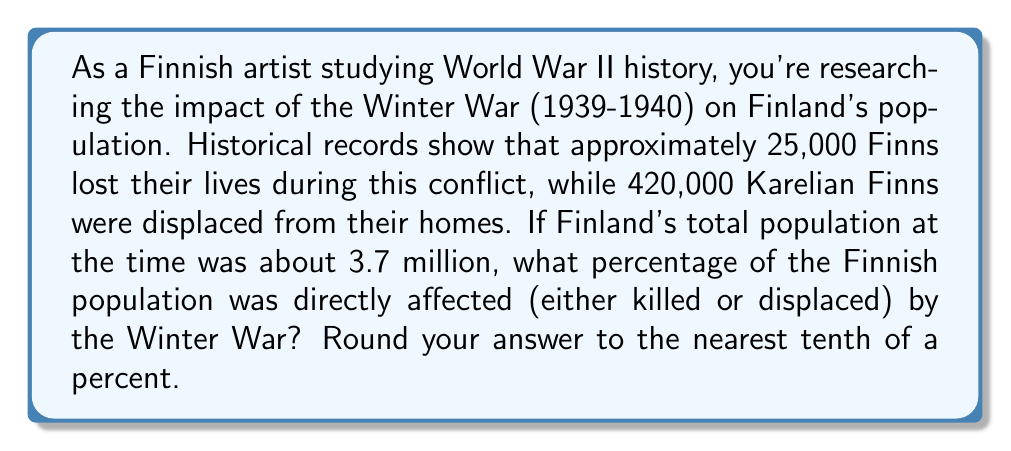What is the answer to this math problem? To solve this problem, we need to follow these steps:

1. Calculate the total number of people directly affected:
   $$ \text{Total affected} = \text{Lives lost} + \text{Displaced} $$
   $$ \text{Total affected} = 25,000 + 420,000 = 445,000 $$

2. Set up the percentage calculation:
   $$ \text{Percentage affected} = \frac{\text{Total affected}}{\text{Total population}} \times 100\% $$

3. Plug in the values:
   $$ \text{Percentage affected} = \frac{445,000}{3,700,000} \times 100\% $$

4. Perform the division:
   $$ \text{Percentage affected} = 0.12027027... \times 100\% = 12.027027...\% $$

5. Round to the nearest tenth of a percent:
   $$ \text{Percentage affected} \approx 12.0\% $$
Answer: 12.0% 